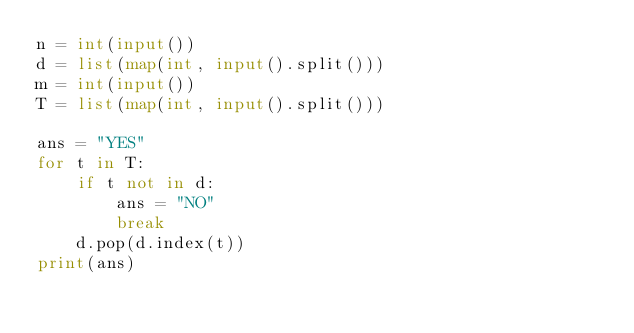Convert code to text. <code><loc_0><loc_0><loc_500><loc_500><_Python_>n = int(input())
d = list(map(int, input().split()))
m = int(input())
T = list(map(int, input().split()))

ans = "YES"
for t in T:
    if t not in d: 
        ans = "NO"
        break
    d.pop(d.index(t))
print(ans)</code> 